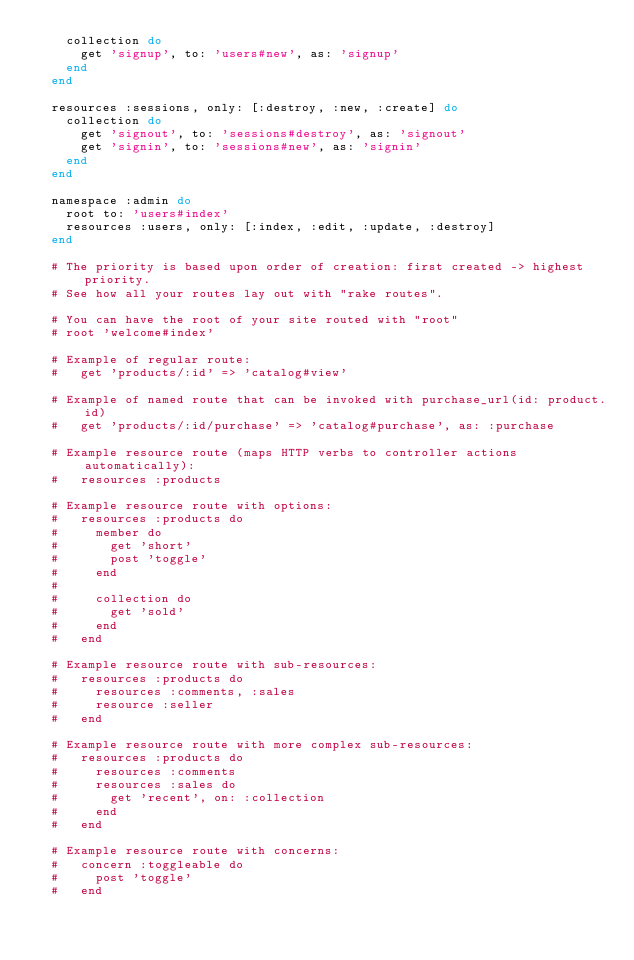<code> <loc_0><loc_0><loc_500><loc_500><_Ruby_>    collection do
      get 'signup', to: 'users#new', as: 'signup'
    end
  end

  resources :sessions, only: [:destroy, :new, :create] do
    collection do
      get 'signout', to: 'sessions#destroy', as: 'signout'
      get 'signin', to: 'sessions#new', as: 'signin'
    end
  end

  namespace :admin do
    root to: 'users#index'
    resources :users, only: [:index, :edit, :update, :destroy]
  end

  # The priority is based upon order of creation: first created -> highest priority.
  # See how all your routes lay out with "rake routes".

  # You can have the root of your site routed with "root"
  # root 'welcome#index'

  # Example of regular route:
  #   get 'products/:id' => 'catalog#view'

  # Example of named route that can be invoked with purchase_url(id: product.id)
  #   get 'products/:id/purchase' => 'catalog#purchase', as: :purchase

  # Example resource route (maps HTTP verbs to controller actions automatically):
  #   resources :products

  # Example resource route with options:
  #   resources :products do
  #     member do
  #       get 'short'
  #       post 'toggle'
  #     end
  #
  #     collection do
  #       get 'sold'
  #     end
  #   end

  # Example resource route with sub-resources:
  #   resources :products do
  #     resources :comments, :sales
  #     resource :seller
  #   end

  # Example resource route with more complex sub-resources:
  #   resources :products do
  #     resources :comments
  #     resources :sales do
  #       get 'recent', on: :collection
  #     end
  #   end

  # Example resource route with concerns:
  #   concern :toggleable do
  #     post 'toggle'
  #   end</code> 